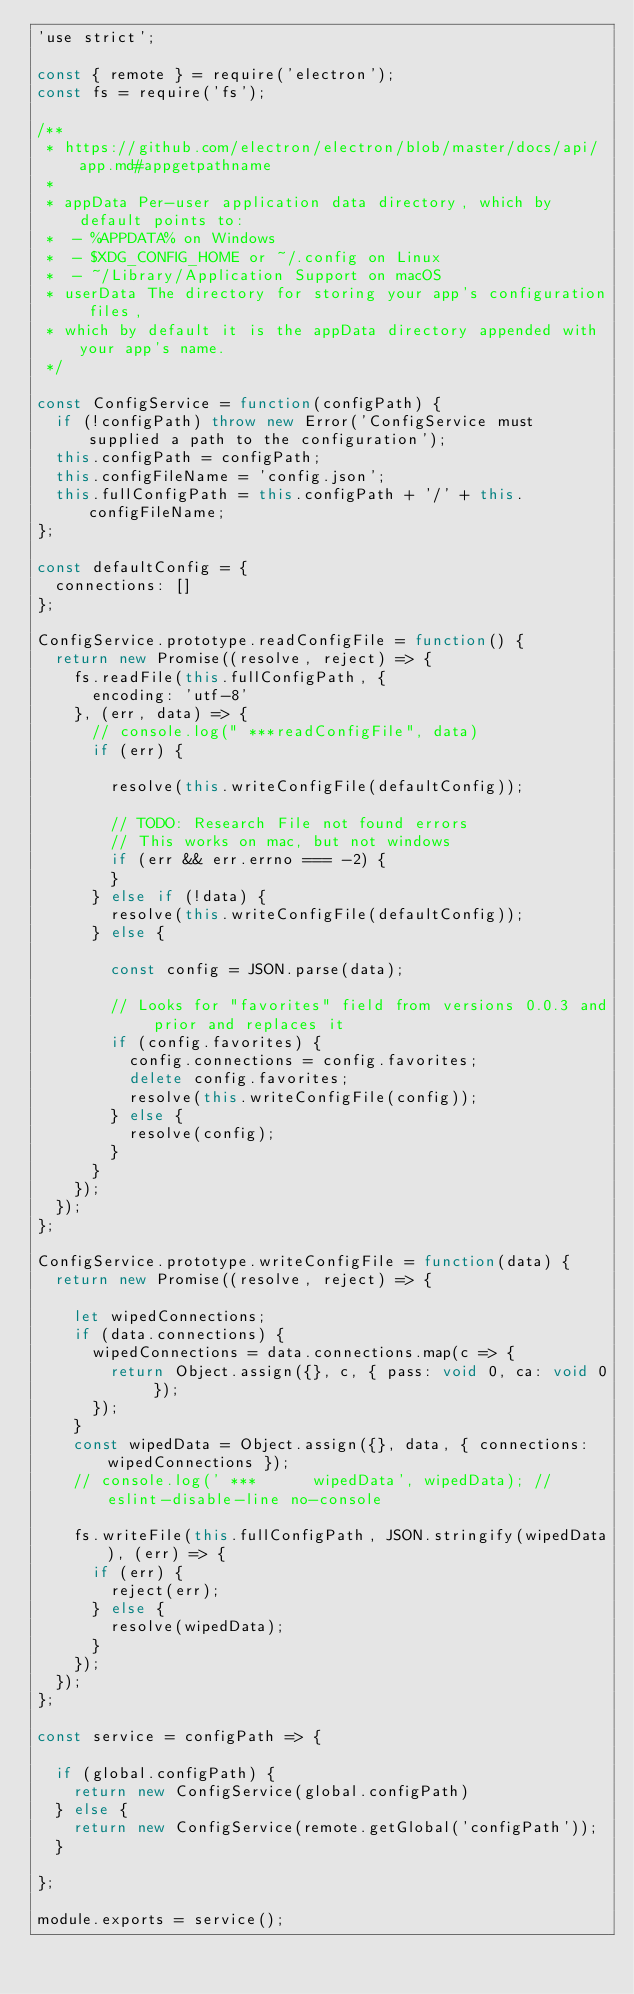Convert code to text. <code><loc_0><loc_0><loc_500><loc_500><_JavaScript_>'use strict';

const { remote } = require('electron');
const fs = require('fs');

/**
 * https://github.com/electron/electron/blob/master/docs/api/app.md#appgetpathname
 *
 * appData Per-user application data directory, which by default points to:
 *  - %APPDATA% on Windows
 *  - $XDG_CONFIG_HOME or ~/.config on Linux
 *  - ~/Library/Application Support on macOS
 * userData The directory for storing your app's configuration files,
 * which by default it is the appData directory appended with your app's name.
 */

const ConfigService = function(configPath) {
  if (!configPath) throw new Error('ConfigService must supplied a path to the configuration');
  this.configPath = configPath;
  this.configFileName = 'config.json';
  this.fullConfigPath = this.configPath + '/' + this.configFileName;
};

const defaultConfig = {
  connections: []
};

ConfigService.prototype.readConfigFile = function() {
  return new Promise((resolve, reject) => {
    fs.readFile(this.fullConfigPath, {
      encoding: 'utf-8'
    }, (err, data) => {
      // console.log(" ***readConfigFile", data)
      if (err) {

        resolve(this.writeConfigFile(defaultConfig));

        // TODO: Research File not found errors
        // This works on mac, but not windows
        if (err && err.errno === -2) {
        }
      } else if (!data) {
        resolve(this.writeConfigFile(defaultConfig));
      } else {

        const config = JSON.parse(data);

        // Looks for "favorites" field from versions 0.0.3 and prior and replaces it
        if (config.favorites) {
          config.connections = config.favorites;
          delete config.favorites;
          resolve(this.writeConfigFile(config));
        } else {
          resolve(config);
        }
      }
    });
  });
};

ConfigService.prototype.writeConfigFile = function(data) {
  return new Promise((resolve, reject) => {

    let wipedConnections;
    if (data.connections) {
      wipedConnections = data.connections.map(c => {
        return Object.assign({}, c, { pass: void 0, ca: void 0 });
      });
    }
    const wipedData = Object.assign({}, data, { connections: wipedConnections });
    // console.log(' ***      wipedData', wipedData); // eslint-disable-line no-console

    fs.writeFile(this.fullConfigPath, JSON.stringify(wipedData), (err) => {
      if (err) {
        reject(err);
      } else {
        resolve(wipedData);
      }
    });
  });
};

const service = configPath => {

  if (global.configPath) {
    return new ConfigService(global.configPath)
  } else {
    return new ConfigService(remote.getGlobal('configPath'));
  }

};

module.exports = service();
</code> 